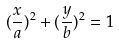Convert formula to latex. <formula><loc_0><loc_0><loc_500><loc_500>( \frac { x } { a } ) ^ { 2 } + ( \frac { y } { b } ) ^ { 2 } = 1</formula> 